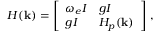Convert formula to latex. <formula><loc_0><loc_0><loc_500><loc_500>H ( \mathbf k ) = \left [ \begin{array} { l l } { \omega _ { e } I } & { g I } \\ { g I } & { H _ { p } ( \mathbf k ) } \end{array} \right ] \, ,</formula> 